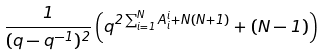<formula> <loc_0><loc_0><loc_500><loc_500>\frac { 1 } { ( q - q ^ { - 1 } ) ^ { 2 } } \left ( q ^ { 2 \sum _ { i = 1 } ^ { N } A _ { i } ^ { i } + N ( N + 1 ) } + ( N - 1 ) \right )</formula> 